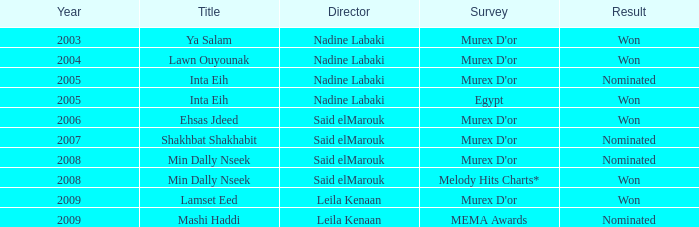What is the result for director Said Elmarouk before 2008? Won, Nominated. 